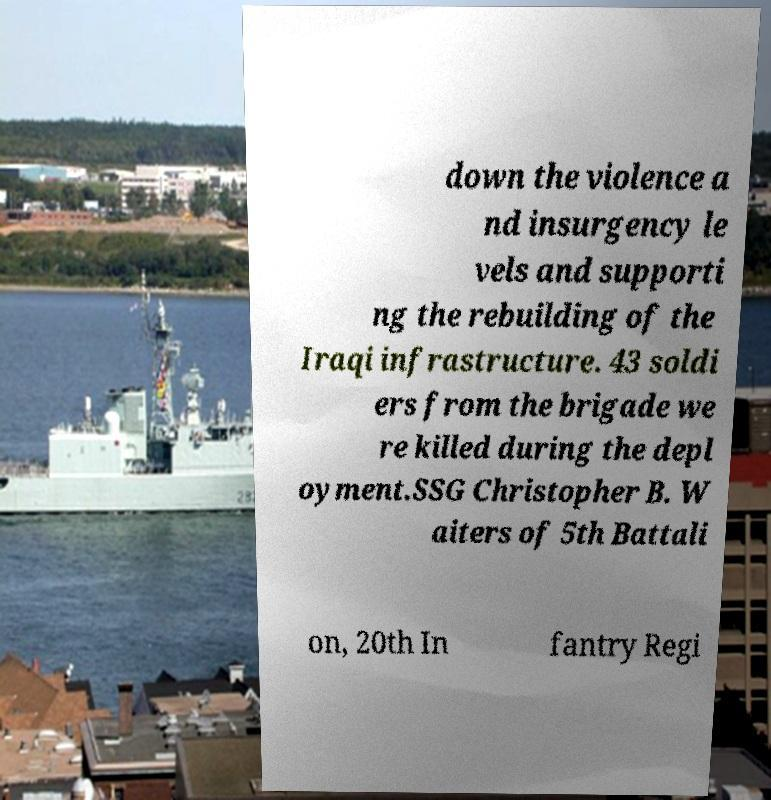I need the written content from this picture converted into text. Can you do that? down the violence a nd insurgency le vels and supporti ng the rebuilding of the Iraqi infrastructure. 43 soldi ers from the brigade we re killed during the depl oyment.SSG Christopher B. W aiters of 5th Battali on, 20th In fantry Regi 